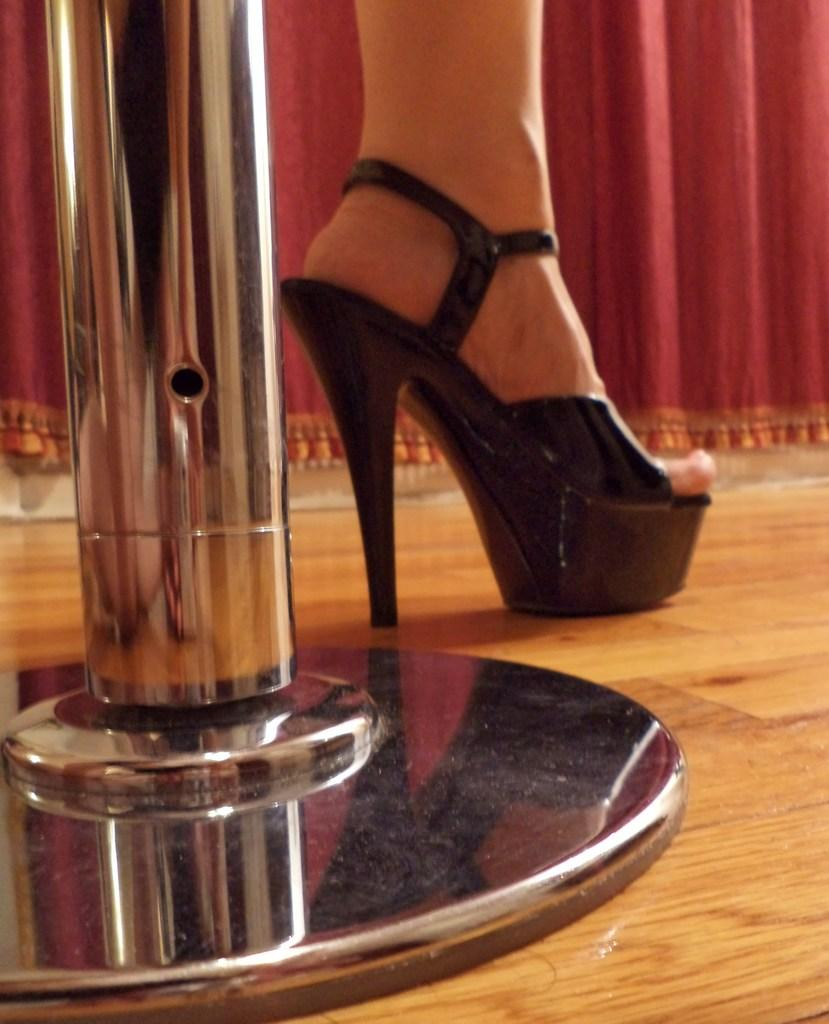What can be seen in the image related to a woman's leg? There is a woman's leg with a shoe in the image. How is the shoe positioned in the image? The shoe is placed on the ground. What is on the left side of the image? There is a pole on the left side of the image. What can be seen in the background of the image? There is a curtain in the background of the image. How much honey is on the desk in the image? There is no desk or honey present in the image. What type of ticket is visible in the image? There is no ticket present in the image. 